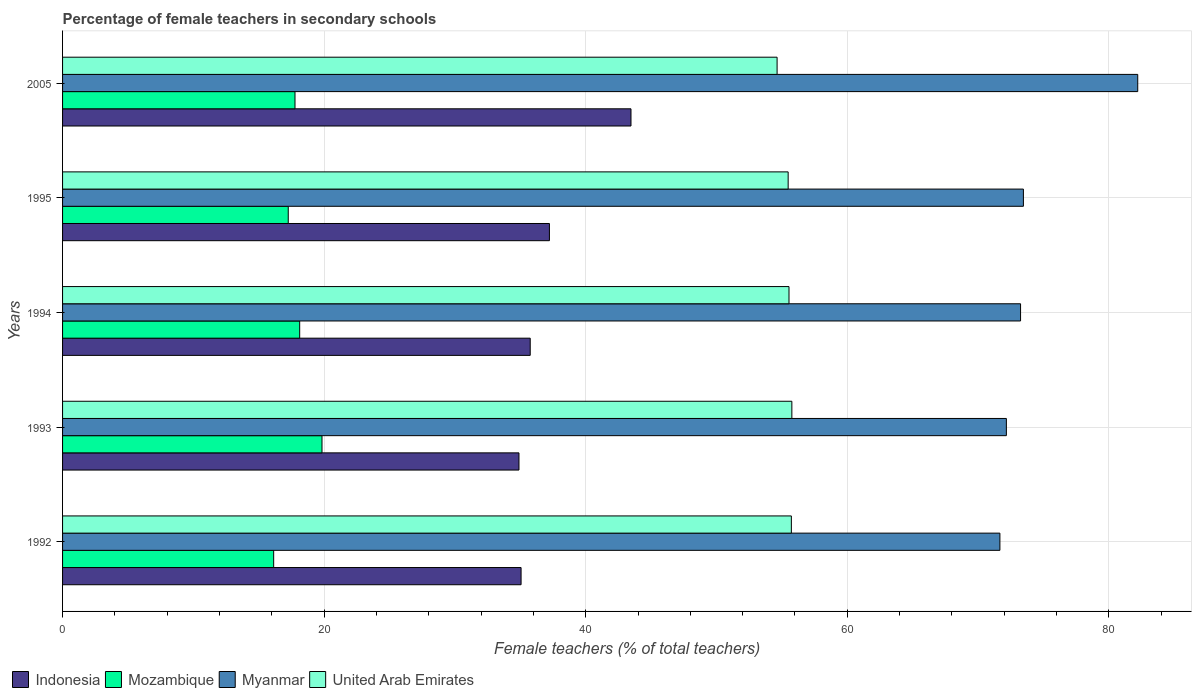How many different coloured bars are there?
Your response must be concise. 4. Are the number of bars per tick equal to the number of legend labels?
Provide a short and direct response. Yes. Are the number of bars on each tick of the Y-axis equal?
Offer a very short reply. Yes. How many bars are there on the 3rd tick from the bottom?
Provide a succinct answer. 4. What is the label of the 2nd group of bars from the top?
Ensure brevity in your answer.  1995. What is the percentage of female teachers in United Arab Emirates in 1993?
Your answer should be very brief. 55.77. Across all years, what is the maximum percentage of female teachers in United Arab Emirates?
Offer a very short reply. 55.77. Across all years, what is the minimum percentage of female teachers in Indonesia?
Provide a succinct answer. 34.9. What is the total percentage of female teachers in Myanmar in the graph?
Offer a very short reply. 372.78. What is the difference between the percentage of female teachers in Myanmar in 1992 and that in 1993?
Your response must be concise. -0.5. What is the difference between the percentage of female teachers in Myanmar in 1994 and the percentage of female teachers in Indonesia in 1992?
Your answer should be very brief. 38.19. What is the average percentage of female teachers in United Arab Emirates per year?
Your answer should be compact. 55.43. In the year 2005, what is the difference between the percentage of female teachers in Myanmar and percentage of female teachers in United Arab Emirates?
Keep it short and to the point. 27.58. In how many years, is the percentage of female teachers in Myanmar greater than 32 %?
Make the answer very short. 5. What is the ratio of the percentage of female teachers in Mozambique in 1992 to that in 1995?
Ensure brevity in your answer.  0.94. What is the difference between the highest and the second highest percentage of female teachers in United Arab Emirates?
Your response must be concise. 0.04. What is the difference between the highest and the lowest percentage of female teachers in Mozambique?
Your response must be concise. 3.7. Is the sum of the percentage of female teachers in Indonesia in 1992 and 1994 greater than the maximum percentage of female teachers in Mozambique across all years?
Provide a succinct answer. Yes. Is it the case that in every year, the sum of the percentage of female teachers in Indonesia and percentage of female teachers in Mozambique is greater than the sum of percentage of female teachers in United Arab Emirates and percentage of female teachers in Myanmar?
Your answer should be very brief. No. What does the 1st bar from the top in 1994 represents?
Your response must be concise. United Arab Emirates. What does the 2nd bar from the bottom in 2005 represents?
Make the answer very short. Mozambique. Are all the bars in the graph horizontal?
Make the answer very short. Yes. How many years are there in the graph?
Make the answer very short. 5. Does the graph contain grids?
Your answer should be compact. Yes. How are the legend labels stacked?
Ensure brevity in your answer.  Horizontal. What is the title of the graph?
Provide a succinct answer. Percentage of female teachers in secondary schools. What is the label or title of the X-axis?
Your answer should be very brief. Female teachers (% of total teachers). What is the Female teachers (% of total teachers) of Indonesia in 1992?
Your answer should be compact. 35.06. What is the Female teachers (% of total teachers) of Mozambique in 1992?
Your response must be concise. 16.14. What is the Female teachers (% of total teachers) in Myanmar in 1992?
Your answer should be very brief. 71.67. What is the Female teachers (% of total teachers) in United Arab Emirates in 1992?
Your answer should be compact. 55.73. What is the Female teachers (% of total teachers) of Indonesia in 1993?
Ensure brevity in your answer.  34.9. What is the Female teachers (% of total teachers) in Mozambique in 1993?
Provide a short and direct response. 19.84. What is the Female teachers (% of total teachers) of Myanmar in 1993?
Provide a succinct answer. 72.17. What is the Female teachers (% of total teachers) in United Arab Emirates in 1993?
Provide a short and direct response. 55.77. What is the Female teachers (% of total teachers) in Indonesia in 1994?
Keep it short and to the point. 35.76. What is the Female teachers (% of total teachers) in Mozambique in 1994?
Provide a short and direct response. 18.13. What is the Female teachers (% of total teachers) in Myanmar in 1994?
Provide a succinct answer. 73.25. What is the Female teachers (% of total teachers) of United Arab Emirates in 1994?
Provide a short and direct response. 55.55. What is the Female teachers (% of total teachers) of Indonesia in 1995?
Make the answer very short. 37.23. What is the Female teachers (% of total teachers) of Mozambique in 1995?
Offer a very short reply. 17.26. What is the Female teachers (% of total teachers) in Myanmar in 1995?
Provide a succinct answer. 73.47. What is the Female teachers (% of total teachers) of United Arab Emirates in 1995?
Your response must be concise. 55.48. What is the Female teachers (% of total teachers) in Indonesia in 2005?
Offer a terse response. 43.46. What is the Female teachers (% of total teachers) of Mozambique in 2005?
Provide a short and direct response. 17.77. What is the Female teachers (% of total teachers) in Myanmar in 2005?
Offer a terse response. 82.21. What is the Female teachers (% of total teachers) in United Arab Emirates in 2005?
Your answer should be very brief. 54.64. Across all years, what is the maximum Female teachers (% of total teachers) in Indonesia?
Keep it short and to the point. 43.46. Across all years, what is the maximum Female teachers (% of total teachers) of Mozambique?
Make the answer very short. 19.84. Across all years, what is the maximum Female teachers (% of total teachers) in Myanmar?
Offer a terse response. 82.21. Across all years, what is the maximum Female teachers (% of total teachers) of United Arab Emirates?
Make the answer very short. 55.77. Across all years, what is the minimum Female teachers (% of total teachers) in Indonesia?
Provide a succinct answer. 34.9. Across all years, what is the minimum Female teachers (% of total teachers) of Mozambique?
Offer a very short reply. 16.14. Across all years, what is the minimum Female teachers (% of total teachers) in Myanmar?
Provide a succinct answer. 71.67. Across all years, what is the minimum Female teachers (% of total teachers) in United Arab Emirates?
Offer a very short reply. 54.64. What is the total Female teachers (% of total teachers) in Indonesia in the graph?
Offer a terse response. 186.41. What is the total Female teachers (% of total teachers) of Mozambique in the graph?
Provide a succinct answer. 89.14. What is the total Female teachers (% of total teachers) in Myanmar in the graph?
Provide a short and direct response. 372.78. What is the total Female teachers (% of total teachers) of United Arab Emirates in the graph?
Your response must be concise. 277.16. What is the difference between the Female teachers (% of total teachers) in Indonesia in 1992 and that in 1993?
Offer a terse response. 0.16. What is the difference between the Female teachers (% of total teachers) in Mozambique in 1992 and that in 1993?
Offer a terse response. -3.7. What is the difference between the Female teachers (% of total teachers) of Myanmar in 1992 and that in 1993?
Give a very brief answer. -0.5. What is the difference between the Female teachers (% of total teachers) in United Arab Emirates in 1992 and that in 1993?
Give a very brief answer. -0.04. What is the difference between the Female teachers (% of total teachers) of Indonesia in 1992 and that in 1994?
Your answer should be very brief. -0.7. What is the difference between the Female teachers (% of total teachers) in Mozambique in 1992 and that in 1994?
Your answer should be compact. -1.99. What is the difference between the Female teachers (% of total teachers) in Myanmar in 1992 and that in 1994?
Your response must be concise. -1.58. What is the difference between the Female teachers (% of total teachers) of United Arab Emirates in 1992 and that in 1994?
Offer a terse response. 0.18. What is the difference between the Female teachers (% of total teachers) of Indonesia in 1992 and that in 1995?
Offer a terse response. -2.17. What is the difference between the Female teachers (% of total teachers) in Mozambique in 1992 and that in 1995?
Offer a very short reply. -1.11. What is the difference between the Female teachers (% of total teachers) in Myanmar in 1992 and that in 1995?
Offer a very short reply. -1.8. What is the difference between the Female teachers (% of total teachers) in United Arab Emirates in 1992 and that in 1995?
Provide a short and direct response. 0.24. What is the difference between the Female teachers (% of total teachers) in Indonesia in 1992 and that in 2005?
Ensure brevity in your answer.  -8.4. What is the difference between the Female teachers (% of total teachers) in Mozambique in 1992 and that in 2005?
Your response must be concise. -1.63. What is the difference between the Female teachers (% of total teachers) in Myanmar in 1992 and that in 2005?
Your answer should be compact. -10.54. What is the difference between the Female teachers (% of total teachers) in United Arab Emirates in 1992 and that in 2005?
Give a very brief answer. 1.09. What is the difference between the Female teachers (% of total teachers) of Indonesia in 1993 and that in 1994?
Your response must be concise. -0.86. What is the difference between the Female teachers (% of total teachers) of Mozambique in 1993 and that in 1994?
Offer a terse response. 1.71. What is the difference between the Female teachers (% of total teachers) in Myanmar in 1993 and that in 1994?
Give a very brief answer. -1.08. What is the difference between the Female teachers (% of total teachers) of United Arab Emirates in 1993 and that in 1994?
Provide a succinct answer. 0.22. What is the difference between the Female teachers (% of total teachers) in Indonesia in 1993 and that in 1995?
Offer a very short reply. -2.33. What is the difference between the Female teachers (% of total teachers) of Mozambique in 1993 and that in 1995?
Your answer should be very brief. 2.58. What is the difference between the Female teachers (% of total teachers) in Myanmar in 1993 and that in 1995?
Ensure brevity in your answer.  -1.3. What is the difference between the Female teachers (% of total teachers) of United Arab Emirates in 1993 and that in 1995?
Make the answer very short. 0.28. What is the difference between the Female teachers (% of total teachers) of Indonesia in 1993 and that in 2005?
Keep it short and to the point. -8.57. What is the difference between the Female teachers (% of total teachers) in Mozambique in 1993 and that in 2005?
Provide a short and direct response. 2.07. What is the difference between the Female teachers (% of total teachers) in Myanmar in 1993 and that in 2005?
Offer a terse response. -10.04. What is the difference between the Female teachers (% of total teachers) in United Arab Emirates in 1993 and that in 2005?
Ensure brevity in your answer.  1.13. What is the difference between the Female teachers (% of total teachers) of Indonesia in 1994 and that in 1995?
Your answer should be very brief. -1.47. What is the difference between the Female teachers (% of total teachers) of Mozambique in 1994 and that in 1995?
Offer a terse response. 0.87. What is the difference between the Female teachers (% of total teachers) of Myanmar in 1994 and that in 1995?
Provide a short and direct response. -0.22. What is the difference between the Female teachers (% of total teachers) of United Arab Emirates in 1994 and that in 1995?
Your answer should be very brief. 0.06. What is the difference between the Female teachers (% of total teachers) of Indonesia in 1994 and that in 2005?
Provide a short and direct response. -7.71. What is the difference between the Female teachers (% of total teachers) of Mozambique in 1994 and that in 2005?
Your answer should be compact. 0.36. What is the difference between the Female teachers (% of total teachers) in Myanmar in 1994 and that in 2005?
Provide a short and direct response. -8.96. What is the difference between the Female teachers (% of total teachers) of United Arab Emirates in 1994 and that in 2005?
Offer a terse response. 0.91. What is the difference between the Female teachers (% of total teachers) in Indonesia in 1995 and that in 2005?
Your answer should be compact. -6.24. What is the difference between the Female teachers (% of total teachers) of Mozambique in 1995 and that in 2005?
Make the answer very short. -0.52. What is the difference between the Female teachers (% of total teachers) of Myanmar in 1995 and that in 2005?
Offer a terse response. -8.74. What is the difference between the Female teachers (% of total teachers) of United Arab Emirates in 1995 and that in 2005?
Provide a succinct answer. 0.85. What is the difference between the Female teachers (% of total teachers) of Indonesia in 1992 and the Female teachers (% of total teachers) of Mozambique in 1993?
Provide a short and direct response. 15.22. What is the difference between the Female teachers (% of total teachers) of Indonesia in 1992 and the Female teachers (% of total teachers) of Myanmar in 1993?
Provide a succinct answer. -37.11. What is the difference between the Female teachers (% of total teachers) of Indonesia in 1992 and the Female teachers (% of total teachers) of United Arab Emirates in 1993?
Offer a terse response. -20.71. What is the difference between the Female teachers (% of total teachers) in Mozambique in 1992 and the Female teachers (% of total teachers) in Myanmar in 1993?
Offer a very short reply. -56.03. What is the difference between the Female teachers (% of total teachers) of Mozambique in 1992 and the Female teachers (% of total teachers) of United Arab Emirates in 1993?
Your response must be concise. -39.62. What is the difference between the Female teachers (% of total teachers) of Myanmar in 1992 and the Female teachers (% of total teachers) of United Arab Emirates in 1993?
Your answer should be compact. 15.91. What is the difference between the Female teachers (% of total teachers) in Indonesia in 1992 and the Female teachers (% of total teachers) in Mozambique in 1994?
Your answer should be very brief. 16.93. What is the difference between the Female teachers (% of total teachers) in Indonesia in 1992 and the Female teachers (% of total teachers) in Myanmar in 1994?
Your response must be concise. -38.19. What is the difference between the Female teachers (% of total teachers) of Indonesia in 1992 and the Female teachers (% of total teachers) of United Arab Emirates in 1994?
Offer a very short reply. -20.49. What is the difference between the Female teachers (% of total teachers) of Mozambique in 1992 and the Female teachers (% of total teachers) of Myanmar in 1994?
Provide a succinct answer. -57.11. What is the difference between the Female teachers (% of total teachers) in Mozambique in 1992 and the Female teachers (% of total teachers) in United Arab Emirates in 1994?
Provide a short and direct response. -39.4. What is the difference between the Female teachers (% of total teachers) of Myanmar in 1992 and the Female teachers (% of total teachers) of United Arab Emirates in 1994?
Your answer should be very brief. 16.13. What is the difference between the Female teachers (% of total teachers) of Indonesia in 1992 and the Female teachers (% of total teachers) of Mozambique in 1995?
Make the answer very short. 17.8. What is the difference between the Female teachers (% of total teachers) in Indonesia in 1992 and the Female teachers (% of total teachers) in Myanmar in 1995?
Your answer should be very brief. -38.41. What is the difference between the Female teachers (% of total teachers) of Indonesia in 1992 and the Female teachers (% of total teachers) of United Arab Emirates in 1995?
Your answer should be very brief. -20.42. What is the difference between the Female teachers (% of total teachers) of Mozambique in 1992 and the Female teachers (% of total teachers) of Myanmar in 1995?
Provide a short and direct response. -57.33. What is the difference between the Female teachers (% of total teachers) in Mozambique in 1992 and the Female teachers (% of total teachers) in United Arab Emirates in 1995?
Give a very brief answer. -39.34. What is the difference between the Female teachers (% of total teachers) in Myanmar in 1992 and the Female teachers (% of total teachers) in United Arab Emirates in 1995?
Your answer should be very brief. 16.19. What is the difference between the Female teachers (% of total teachers) of Indonesia in 1992 and the Female teachers (% of total teachers) of Mozambique in 2005?
Keep it short and to the point. 17.29. What is the difference between the Female teachers (% of total teachers) in Indonesia in 1992 and the Female teachers (% of total teachers) in Myanmar in 2005?
Make the answer very short. -47.15. What is the difference between the Female teachers (% of total teachers) of Indonesia in 1992 and the Female teachers (% of total teachers) of United Arab Emirates in 2005?
Your answer should be compact. -19.58. What is the difference between the Female teachers (% of total teachers) in Mozambique in 1992 and the Female teachers (% of total teachers) in Myanmar in 2005?
Your answer should be compact. -66.07. What is the difference between the Female teachers (% of total teachers) in Mozambique in 1992 and the Female teachers (% of total teachers) in United Arab Emirates in 2005?
Provide a short and direct response. -38.49. What is the difference between the Female teachers (% of total teachers) of Myanmar in 1992 and the Female teachers (% of total teachers) of United Arab Emirates in 2005?
Provide a succinct answer. 17.04. What is the difference between the Female teachers (% of total teachers) of Indonesia in 1993 and the Female teachers (% of total teachers) of Mozambique in 1994?
Keep it short and to the point. 16.77. What is the difference between the Female teachers (% of total teachers) of Indonesia in 1993 and the Female teachers (% of total teachers) of Myanmar in 1994?
Provide a short and direct response. -38.35. What is the difference between the Female teachers (% of total teachers) of Indonesia in 1993 and the Female teachers (% of total teachers) of United Arab Emirates in 1994?
Your answer should be compact. -20.65. What is the difference between the Female teachers (% of total teachers) in Mozambique in 1993 and the Female teachers (% of total teachers) in Myanmar in 1994?
Offer a terse response. -53.41. What is the difference between the Female teachers (% of total teachers) in Mozambique in 1993 and the Female teachers (% of total teachers) in United Arab Emirates in 1994?
Provide a succinct answer. -35.71. What is the difference between the Female teachers (% of total teachers) in Myanmar in 1993 and the Female teachers (% of total teachers) in United Arab Emirates in 1994?
Your answer should be very brief. 16.62. What is the difference between the Female teachers (% of total teachers) in Indonesia in 1993 and the Female teachers (% of total teachers) in Mozambique in 1995?
Ensure brevity in your answer.  17.64. What is the difference between the Female teachers (% of total teachers) of Indonesia in 1993 and the Female teachers (% of total teachers) of Myanmar in 1995?
Keep it short and to the point. -38.57. What is the difference between the Female teachers (% of total teachers) of Indonesia in 1993 and the Female teachers (% of total teachers) of United Arab Emirates in 1995?
Keep it short and to the point. -20.58. What is the difference between the Female teachers (% of total teachers) of Mozambique in 1993 and the Female teachers (% of total teachers) of Myanmar in 1995?
Ensure brevity in your answer.  -53.63. What is the difference between the Female teachers (% of total teachers) in Mozambique in 1993 and the Female teachers (% of total teachers) in United Arab Emirates in 1995?
Provide a succinct answer. -35.64. What is the difference between the Female teachers (% of total teachers) of Myanmar in 1993 and the Female teachers (% of total teachers) of United Arab Emirates in 1995?
Offer a very short reply. 16.69. What is the difference between the Female teachers (% of total teachers) in Indonesia in 1993 and the Female teachers (% of total teachers) in Mozambique in 2005?
Offer a terse response. 17.13. What is the difference between the Female teachers (% of total teachers) in Indonesia in 1993 and the Female teachers (% of total teachers) in Myanmar in 2005?
Provide a succinct answer. -47.31. What is the difference between the Female teachers (% of total teachers) in Indonesia in 1993 and the Female teachers (% of total teachers) in United Arab Emirates in 2005?
Offer a terse response. -19.74. What is the difference between the Female teachers (% of total teachers) of Mozambique in 1993 and the Female teachers (% of total teachers) of Myanmar in 2005?
Offer a terse response. -62.37. What is the difference between the Female teachers (% of total teachers) of Mozambique in 1993 and the Female teachers (% of total teachers) of United Arab Emirates in 2005?
Offer a terse response. -34.8. What is the difference between the Female teachers (% of total teachers) in Myanmar in 1993 and the Female teachers (% of total teachers) in United Arab Emirates in 2005?
Ensure brevity in your answer.  17.53. What is the difference between the Female teachers (% of total teachers) in Indonesia in 1994 and the Female teachers (% of total teachers) in Mozambique in 1995?
Provide a succinct answer. 18.5. What is the difference between the Female teachers (% of total teachers) of Indonesia in 1994 and the Female teachers (% of total teachers) of Myanmar in 1995?
Provide a short and direct response. -37.71. What is the difference between the Female teachers (% of total teachers) in Indonesia in 1994 and the Female teachers (% of total teachers) in United Arab Emirates in 1995?
Your response must be concise. -19.72. What is the difference between the Female teachers (% of total teachers) in Mozambique in 1994 and the Female teachers (% of total teachers) in Myanmar in 1995?
Your answer should be very brief. -55.34. What is the difference between the Female teachers (% of total teachers) in Mozambique in 1994 and the Female teachers (% of total teachers) in United Arab Emirates in 1995?
Make the answer very short. -37.35. What is the difference between the Female teachers (% of total teachers) in Myanmar in 1994 and the Female teachers (% of total teachers) in United Arab Emirates in 1995?
Your answer should be very brief. 17.77. What is the difference between the Female teachers (% of total teachers) of Indonesia in 1994 and the Female teachers (% of total teachers) of Mozambique in 2005?
Your answer should be compact. 17.99. What is the difference between the Female teachers (% of total teachers) in Indonesia in 1994 and the Female teachers (% of total teachers) in Myanmar in 2005?
Your answer should be very brief. -46.45. What is the difference between the Female teachers (% of total teachers) of Indonesia in 1994 and the Female teachers (% of total teachers) of United Arab Emirates in 2005?
Keep it short and to the point. -18.88. What is the difference between the Female teachers (% of total teachers) of Mozambique in 1994 and the Female teachers (% of total teachers) of Myanmar in 2005?
Give a very brief answer. -64.08. What is the difference between the Female teachers (% of total teachers) of Mozambique in 1994 and the Female teachers (% of total teachers) of United Arab Emirates in 2005?
Keep it short and to the point. -36.51. What is the difference between the Female teachers (% of total teachers) in Myanmar in 1994 and the Female teachers (% of total teachers) in United Arab Emirates in 2005?
Your response must be concise. 18.62. What is the difference between the Female teachers (% of total teachers) of Indonesia in 1995 and the Female teachers (% of total teachers) of Mozambique in 2005?
Give a very brief answer. 19.45. What is the difference between the Female teachers (% of total teachers) in Indonesia in 1995 and the Female teachers (% of total teachers) in Myanmar in 2005?
Give a very brief answer. -44.99. What is the difference between the Female teachers (% of total teachers) in Indonesia in 1995 and the Female teachers (% of total teachers) in United Arab Emirates in 2005?
Your answer should be compact. -17.41. What is the difference between the Female teachers (% of total teachers) of Mozambique in 1995 and the Female teachers (% of total teachers) of Myanmar in 2005?
Your answer should be very brief. -64.95. What is the difference between the Female teachers (% of total teachers) in Mozambique in 1995 and the Female teachers (% of total teachers) in United Arab Emirates in 2005?
Provide a succinct answer. -37.38. What is the difference between the Female teachers (% of total teachers) of Myanmar in 1995 and the Female teachers (% of total teachers) of United Arab Emirates in 2005?
Give a very brief answer. 18.83. What is the average Female teachers (% of total teachers) of Indonesia per year?
Your answer should be compact. 37.28. What is the average Female teachers (% of total teachers) in Mozambique per year?
Give a very brief answer. 17.83. What is the average Female teachers (% of total teachers) of Myanmar per year?
Your response must be concise. 74.56. What is the average Female teachers (% of total teachers) of United Arab Emirates per year?
Offer a terse response. 55.43. In the year 1992, what is the difference between the Female teachers (% of total teachers) of Indonesia and Female teachers (% of total teachers) of Mozambique?
Keep it short and to the point. 18.92. In the year 1992, what is the difference between the Female teachers (% of total teachers) of Indonesia and Female teachers (% of total teachers) of Myanmar?
Ensure brevity in your answer.  -36.61. In the year 1992, what is the difference between the Female teachers (% of total teachers) of Indonesia and Female teachers (% of total teachers) of United Arab Emirates?
Ensure brevity in your answer.  -20.67. In the year 1992, what is the difference between the Female teachers (% of total teachers) in Mozambique and Female teachers (% of total teachers) in Myanmar?
Ensure brevity in your answer.  -55.53. In the year 1992, what is the difference between the Female teachers (% of total teachers) in Mozambique and Female teachers (% of total teachers) in United Arab Emirates?
Your answer should be compact. -39.58. In the year 1992, what is the difference between the Female teachers (% of total teachers) of Myanmar and Female teachers (% of total teachers) of United Arab Emirates?
Keep it short and to the point. 15.95. In the year 1993, what is the difference between the Female teachers (% of total teachers) of Indonesia and Female teachers (% of total teachers) of Mozambique?
Give a very brief answer. 15.06. In the year 1993, what is the difference between the Female teachers (% of total teachers) in Indonesia and Female teachers (% of total teachers) in Myanmar?
Provide a succinct answer. -37.27. In the year 1993, what is the difference between the Female teachers (% of total teachers) in Indonesia and Female teachers (% of total teachers) in United Arab Emirates?
Your response must be concise. -20.87. In the year 1993, what is the difference between the Female teachers (% of total teachers) of Mozambique and Female teachers (% of total teachers) of Myanmar?
Your response must be concise. -52.33. In the year 1993, what is the difference between the Female teachers (% of total teachers) of Mozambique and Female teachers (% of total teachers) of United Arab Emirates?
Provide a short and direct response. -35.93. In the year 1993, what is the difference between the Female teachers (% of total teachers) of Myanmar and Female teachers (% of total teachers) of United Arab Emirates?
Your response must be concise. 16.4. In the year 1994, what is the difference between the Female teachers (% of total teachers) of Indonesia and Female teachers (% of total teachers) of Mozambique?
Your response must be concise. 17.63. In the year 1994, what is the difference between the Female teachers (% of total teachers) of Indonesia and Female teachers (% of total teachers) of Myanmar?
Keep it short and to the point. -37.49. In the year 1994, what is the difference between the Female teachers (% of total teachers) of Indonesia and Female teachers (% of total teachers) of United Arab Emirates?
Make the answer very short. -19.79. In the year 1994, what is the difference between the Female teachers (% of total teachers) of Mozambique and Female teachers (% of total teachers) of Myanmar?
Provide a succinct answer. -55.12. In the year 1994, what is the difference between the Female teachers (% of total teachers) of Mozambique and Female teachers (% of total teachers) of United Arab Emirates?
Keep it short and to the point. -37.42. In the year 1994, what is the difference between the Female teachers (% of total teachers) in Myanmar and Female teachers (% of total teachers) in United Arab Emirates?
Your answer should be very brief. 17.71. In the year 1995, what is the difference between the Female teachers (% of total teachers) in Indonesia and Female teachers (% of total teachers) in Mozambique?
Provide a short and direct response. 19.97. In the year 1995, what is the difference between the Female teachers (% of total teachers) in Indonesia and Female teachers (% of total teachers) in Myanmar?
Provide a short and direct response. -36.24. In the year 1995, what is the difference between the Female teachers (% of total teachers) of Indonesia and Female teachers (% of total teachers) of United Arab Emirates?
Your answer should be compact. -18.26. In the year 1995, what is the difference between the Female teachers (% of total teachers) of Mozambique and Female teachers (% of total teachers) of Myanmar?
Your answer should be compact. -56.21. In the year 1995, what is the difference between the Female teachers (% of total teachers) of Mozambique and Female teachers (% of total teachers) of United Arab Emirates?
Give a very brief answer. -38.22. In the year 1995, what is the difference between the Female teachers (% of total teachers) of Myanmar and Female teachers (% of total teachers) of United Arab Emirates?
Keep it short and to the point. 17.99. In the year 2005, what is the difference between the Female teachers (% of total teachers) in Indonesia and Female teachers (% of total teachers) in Mozambique?
Your answer should be compact. 25.69. In the year 2005, what is the difference between the Female teachers (% of total teachers) of Indonesia and Female teachers (% of total teachers) of Myanmar?
Provide a succinct answer. -38.75. In the year 2005, what is the difference between the Female teachers (% of total teachers) in Indonesia and Female teachers (% of total teachers) in United Arab Emirates?
Provide a short and direct response. -11.17. In the year 2005, what is the difference between the Female teachers (% of total teachers) of Mozambique and Female teachers (% of total teachers) of Myanmar?
Offer a terse response. -64.44. In the year 2005, what is the difference between the Female teachers (% of total teachers) of Mozambique and Female teachers (% of total teachers) of United Arab Emirates?
Offer a terse response. -36.86. In the year 2005, what is the difference between the Female teachers (% of total teachers) of Myanmar and Female teachers (% of total teachers) of United Arab Emirates?
Offer a terse response. 27.58. What is the ratio of the Female teachers (% of total teachers) of Mozambique in 1992 to that in 1993?
Provide a short and direct response. 0.81. What is the ratio of the Female teachers (% of total teachers) in United Arab Emirates in 1992 to that in 1993?
Offer a terse response. 1. What is the ratio of the Female teachers (% of total teachers) of Indonesia in 1992 to that in 1994?
Provide a short and direct response. 0.98. What is the ratio of the Female teachers (% of total teachers) in Mozambique in 1992 to that in 1994?
Provide a short and direct response. 0.89. What is the ratio of the Female teachers (% of total teachers) of Myanmar in 1992 to that in 1994?
Your response must be concise. 0.98. What is the ratio of the Female teachers (% of total teachers) of Indonesia in 1992 to that in 1995?
Ensure brevity in your answer.  0.94. What is the ratio of the Female teachers (% of total teachers) of Mozambique in 1992 to that in 1995?
Offer a terse response. 0.94. What is the ratio of the Female teachers (% of total teachers) of Myanmar in 1992 to that in 1995?
Make the answer very short. 0.98. What is the ratio of the Female teachers (% of total teachers) in United Arab Emirates in 1992 to that in 1995?
Your answer should be compact. 1. What is the ratio of the Female teachers (% of total teachers) in Indonesia in 1992 to that in 2005?
Offer a very short reply. 0.81. What is the ratio of the Female teachers (% of total teachers) in Mozambique in 1992 to that in 2005?
Keep it short and to the point. 0.91. What is the ratio of the Female teachers (% of total teachers) in Myanmar in 1992 to that in 2005?
Ensure brevity in your answer.  0.87. What is the ratio of the Female teachers (% of total teachers) of Mozambique in 1993 to that in 1994?
Your answer should be very brief. 1.09. What is the ratio of the Female teachers (% of total teachers) in Myanmar in 1993 to that in 1994?
Give a very brief answer. 0.99. What is the ratio of the Female teachers (% of total teachers) of United Arab Emirates in 1993 to that in 1994?
Make the answer very short. 1. What is the ratio of the Female teachers (% of total teachers) of Indonesia in 1993 to that in 1995?
Give a very brief answer. 0.94. What is the ratio of the Female teachers (% of total teachers) in Mozambique in 1993 to that in 1995?
Provide a short and direct response. 1.15. What is the ratio of the Female teachers (% of total teachers) of Myanmar in 1993 to that in 1995?
Your answer should be compact. 0.98. What is the ratio of the Female teachers (% of total teachers) in Indonesia in 1993 to that in 2005?
Offer a terse response. 0.8. What is the ratio of the Female teachers (% of total teachers) of Mozambique in 1993 to that in 2005?
Make the answer very short. 1.12. What is the ratio of the Female teachers (% of total teachers) of Myanmar in 1993 to that in 2005?
Offer a very short reply. 0.88. What is the ratio of the Female teachers (% of total teachers) of United Arab Emirates in 1993 to that in 2005?
Keep it short and to the point. 1.02. What is the ratio of the Female teachers (% of total teachers) in Indonesia in 1994 to that in 1995?
Give a very brief answer. 0.96. What is the ratio of the Female teachers (% of total teachers) of Mozambique in 1994 to that in 1995?
Your response must be concise. 1.05. What is the ratio of the Female teachers (% of total teachers) of Indonesia in 1994 to that in 2005?
Give a very brief answer. 0.82. What is the ratio of the Female teachers (% of total teachers) in Mozambique in 1994 to that in 2005?
Ensure brevity in your answer.  1.02. What is the ratio of the Female teachers (% of total teachers) of Myanmar in 1994 to that in 2005?
Keep it short and to the point. 0.89. What is the ratio of the Female teachers (% of total teachers) in United Arab Emirates in 1994 to that in 2005?
Offer a very short reply. 1.02. What is the ratio of the Female teachers (% of total teachers) in Indonesia in 1995 to that in 2005?
Offer a very short reply. 0.86. What is the ratio of the Female teachers (% of total teachers) in Myanmar in 1995 to that in 2005?
Offer a very short reply. 0.89. What is the ratio of the Female teachers (% of total teachers) of United Arab Emirates in 1995 to that in 2005?
Provide a succinct answer. 1.02. What is the difference between the highest and the second highest Female teachers (% of total teachers) of Indonesia?
Make the answer very short. 6.24. What is the difference between the highest and the second highest Female teachers (% of total teachers) of Mozambique?
Offer a very short reply. 1.71. What is the difference between the highest and the second highest Female teachers (% of total teachers) in Myanmar?
Give a very brief answer. 8.74. What is the difference between the highest and the second highest Female teachers (% of total teachers) of United Arab Emirates?
Offer a terse response. 0.04. What is the difference between the highest and the lowest Female teachers (% of total teachers) of Indonesia?
Offer a terse response. 8.57. What is the difference between the highest and the lowest Female teachers (% of total teachers) in Mozambique?
Provide a succinct answer. 3.7. What is the difference between the highest and the lowest Female teachers (% of total teachers) in Myanmar?
Offer a terse response. 10.54. What is the difference between the highest and the lowest Female teachers (% of total teachers) of United Arab Emirates?
Give a very brief answer. 1.13. 